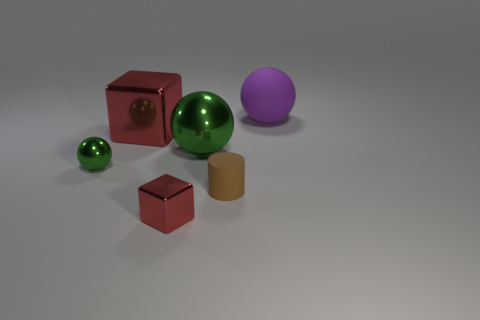Subtract all blue cylinders. Subtract all red blocks. How many cylinders are left? 1 Add 2 large green shiny objects. How many objects exist? 8 Subtract all cylinders. How many objects are left? 5 Add 5 small metallic objects. How many small metallic objects exist? 7 Subtract 0 blue spheres. How many objects are left? 6 Subtract all red spheres. Subtract all tiny green metallic balls. How many objects are left? 5 Add 4 cubes. How many cubes are left? 6 